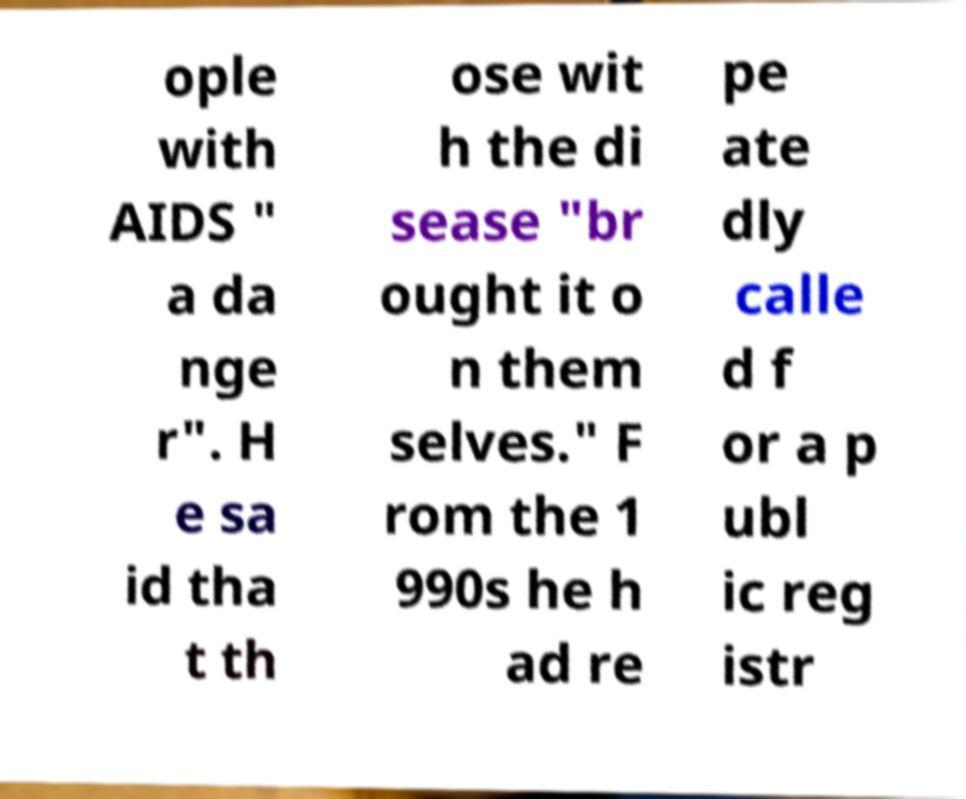What messages or text are displayed in this image? I need them in a readable, typed format. ople with AIDS " a da nge r". H e sa id tha t th ose wit h the di sease "br ought it o n them selves." F rom the 1 990s he h ad re pe ate dly calle d f or a p ubl ic reg istr 